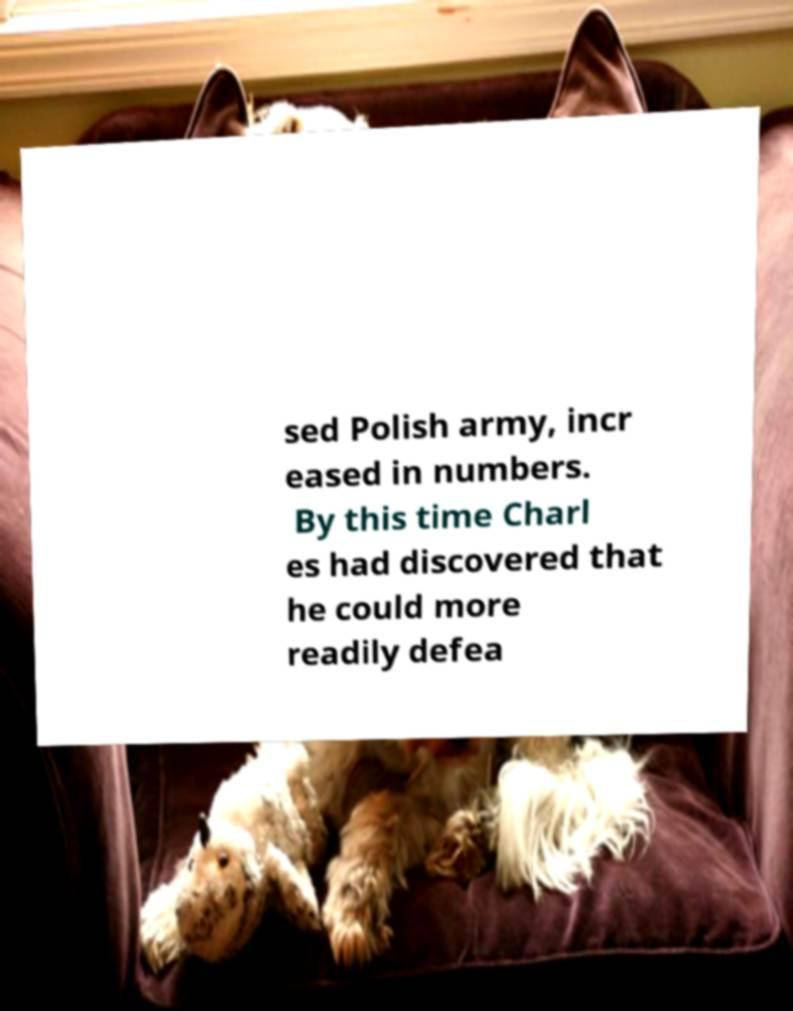Can you read and provide the text displayed in the image?This photo seems to have some interesting text. Can you extract and type it out for me? sed Polish army, incr eased in numbers. By this time Charl es had discovered that he could more readily defea 